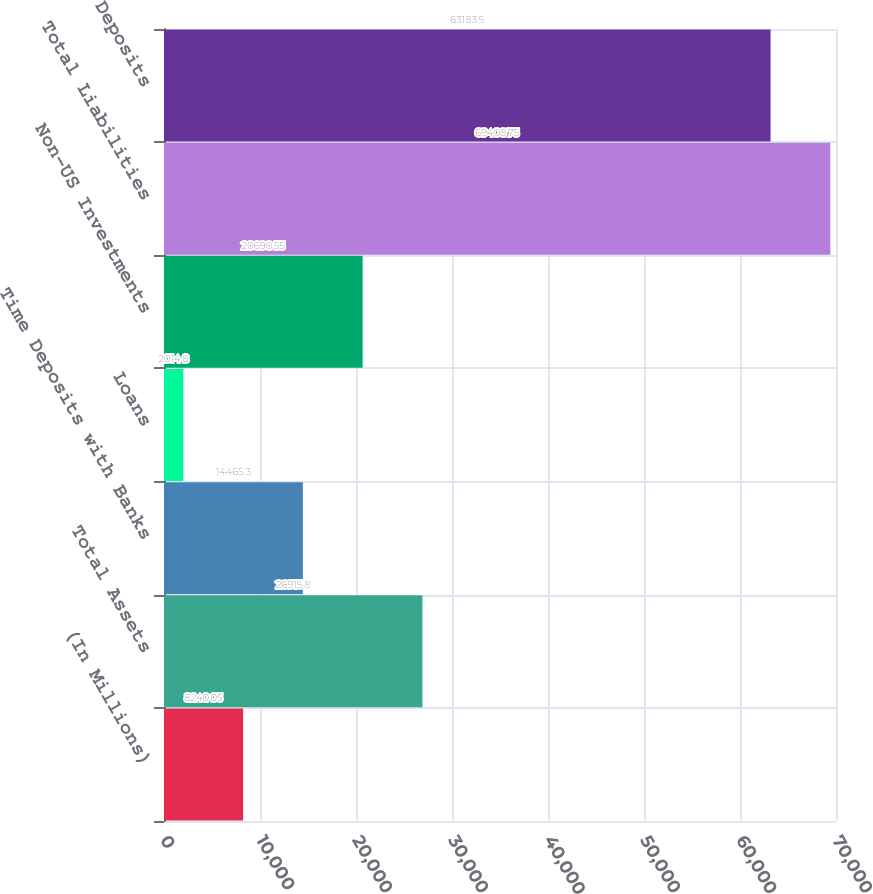Convert chart. <chart><loc_0><loc_0><loc_500><loc_500><bar_chart><fcel>(In Millions)<fcel>Total Assets<fcel>Time Deposits with Banks<fcel>Loans<fcel>Non-US Investments<fcel>Total Liabilities<fcel>Deposits<nl><fcel>8240.05<fcel>26915.8<fcel>14465.3<fcel>2014.8<fcel>20690.5<fcel>69408.8<fcel>63183.5<nl></chart> 